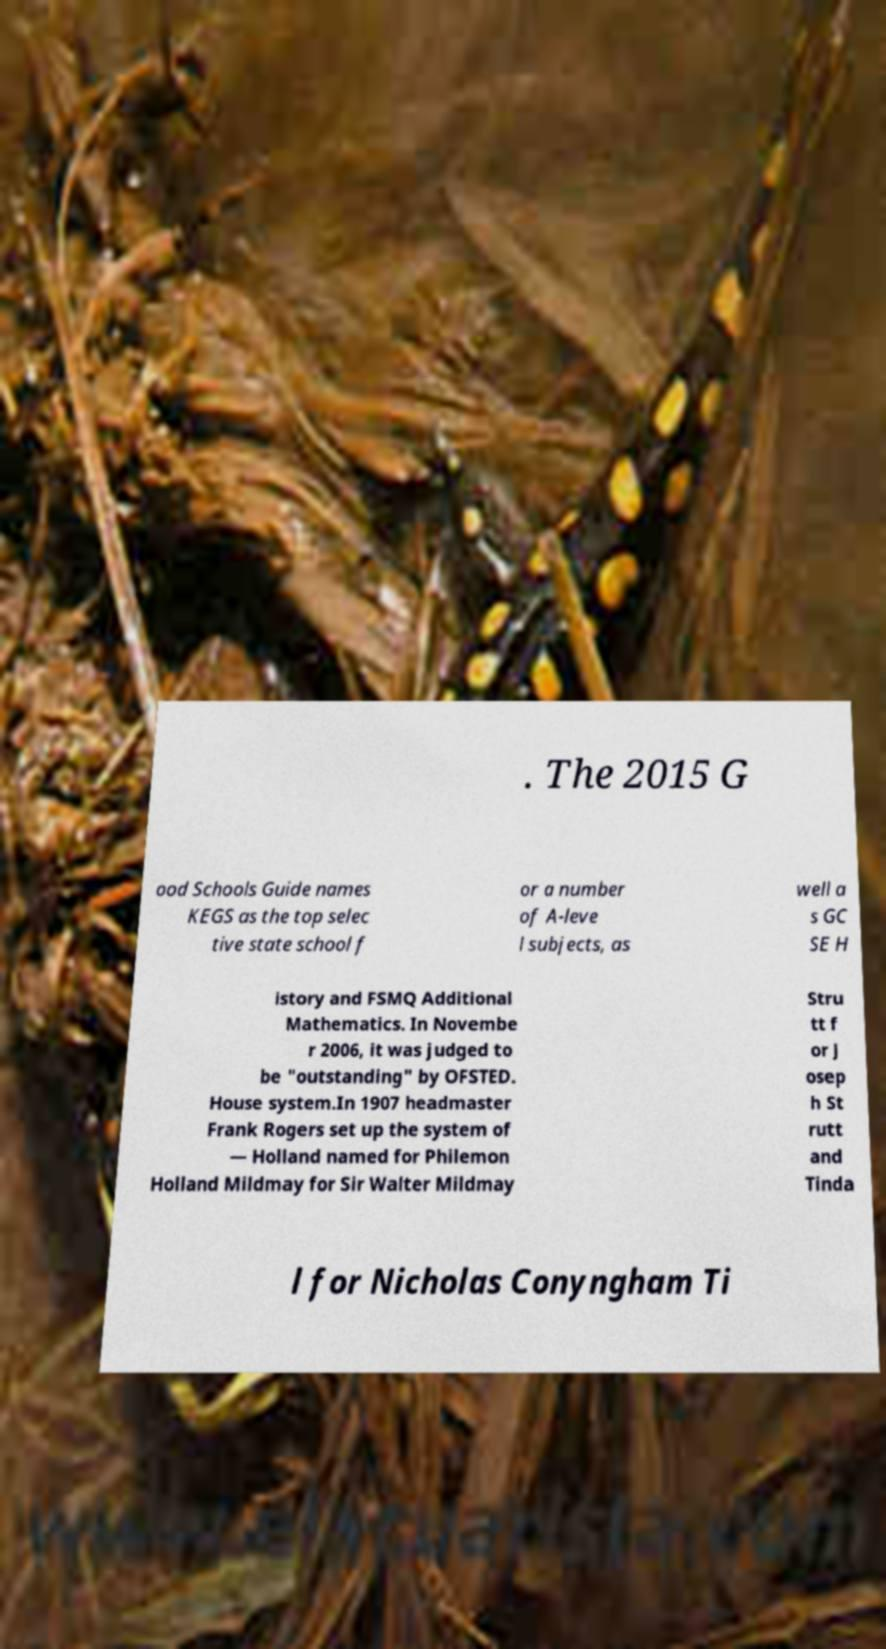Can you read and provide the text displayed in the image?This photo seems to have some interesting text. Can you extract and type it out for me? . The 2015 G ood Schools Guide names KEGS as the top selec tive state school f or a number of A-leve l subjects, as well a s GC SE H istory and FSMQ Additional Mathematics. In Novembe r 2006, it was judged to be "outstanding" by OFSTED. House system.In 1907 headmaster Frank Rogers set up the system of — Holland named for Philemon Holland Mildmay for Sir Walter Mildmay Stru tt f or J osep h St rutt and Tinda l for Nicholas Conyngham Ti 